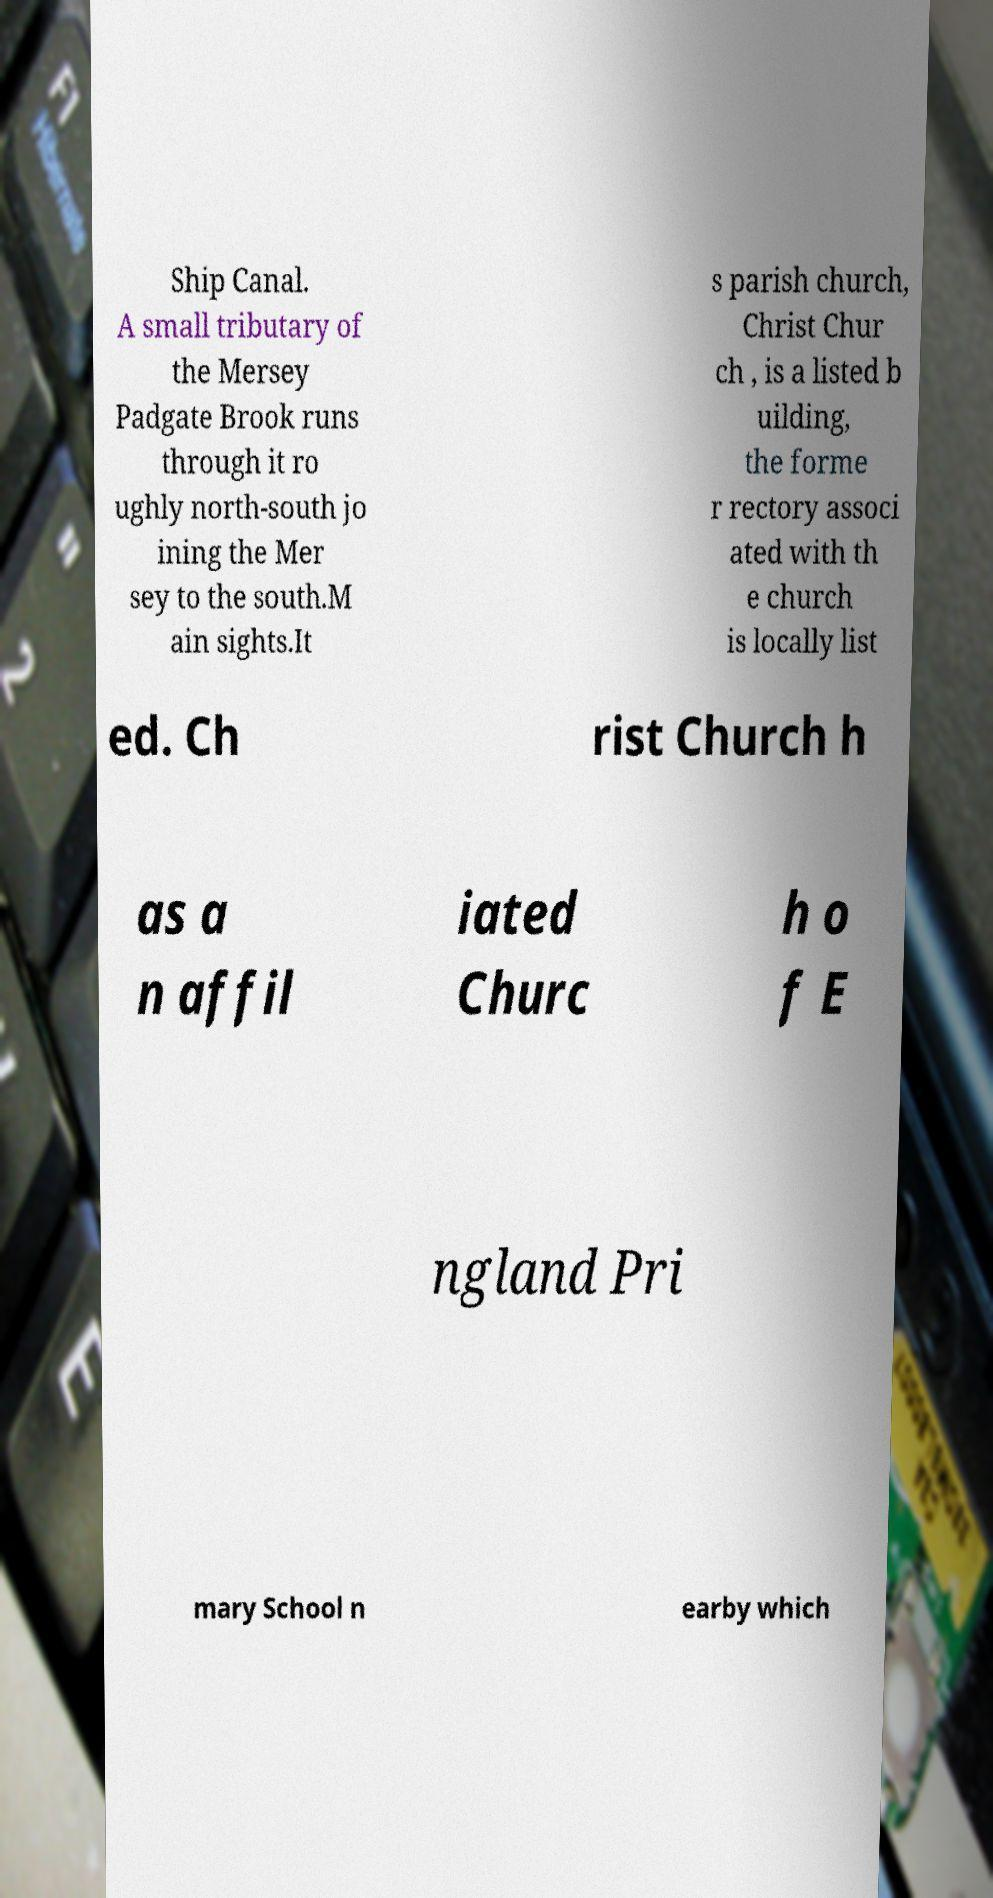Please read and relay the text visible in this image. What does it say? Ship Canal. A small tributary of the Mersey Padgate Brook runs through it ro ughly north-south jo ining the Mer sey to the south.M ain sights.It s parish church, Christ Chur ch , is a listed b uilding, the forme r rectory associ ated with th e church is locally list ed. Ch rist Church h as a n affil iated Churc h o f E ngland Pri mary School n earby which 